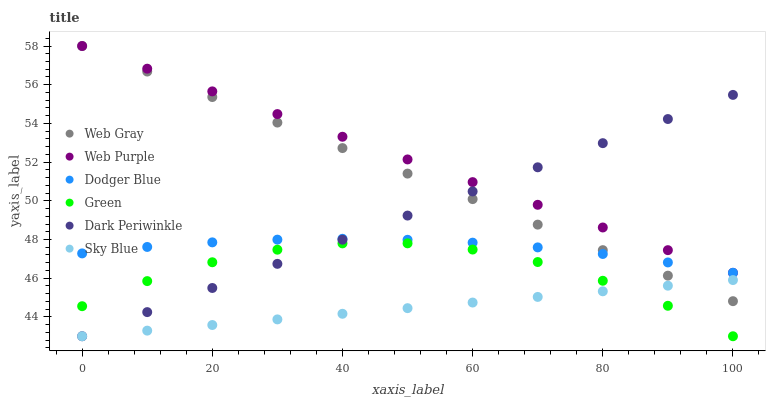Does Sky Blue have the minimum area under the curve?
Answer yes or no. Yes. Does Web Purple have the maximum area under the curve?
Answer yes or no. Yes. Does Green have the minimum area under the curve?
Answer yes or no. No. Does Green have the maximum area under the curve?
Answer yes or no. No. Is Web Purple the smoothest?
Answer yes or no. Yes. Is Green the roughest?
Answer yes or no. Yes. Is Green the smoothest?
Answer yes or no. No. Is Web Purple the roughest?
Answer yes or no. No. Does Green have the lowest value?
Answer yes or no. Yes. Does Web Purple have the lowest value?
Answer yes or no. No. Does Web Purple have the highest value?
Answer yes or no. Yes. Does Green have the highest value?
Answer yes or no. No. Is Green less than Web Purple?
Answer yes or no. Yes. Is Web Purple greater than Sky Blue?
Answer yes or no. Yes. Does Dark Periwinkle intersect Web Purple?
Answer yes or no. Yes. Is Dark Periwinkle less than Web Purple?
Answer yes or no. No. Is Dark Periwinkle greater than Web Purple?
Answer yes or no. No. Does Green intersect Web Purple?
Answer yes or no. No. 